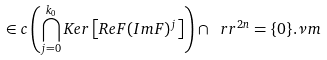Convert formula to latex. <formula><loc_0><loc_0><loc_500><loc_500>\in c \left ( \bigcap _ { j = 0 } ^ { k _ { 0 } } K e r \left [ R e F ( I m F ) ^ { j } \right ] \right ) \cap \ r r ^ { 2 n } = \{ 0 \} . \nu m</formula> 